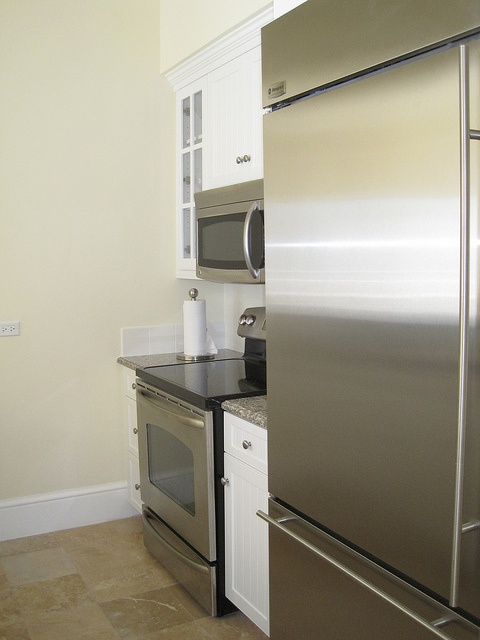Describe the objects in this image and their specific colors. I can see refrigerator in beige, gray, lightgray, and black tones, oven in beige, gray, and black tones, and microwave in beige, gray, black, and darkgray tones in this image. 